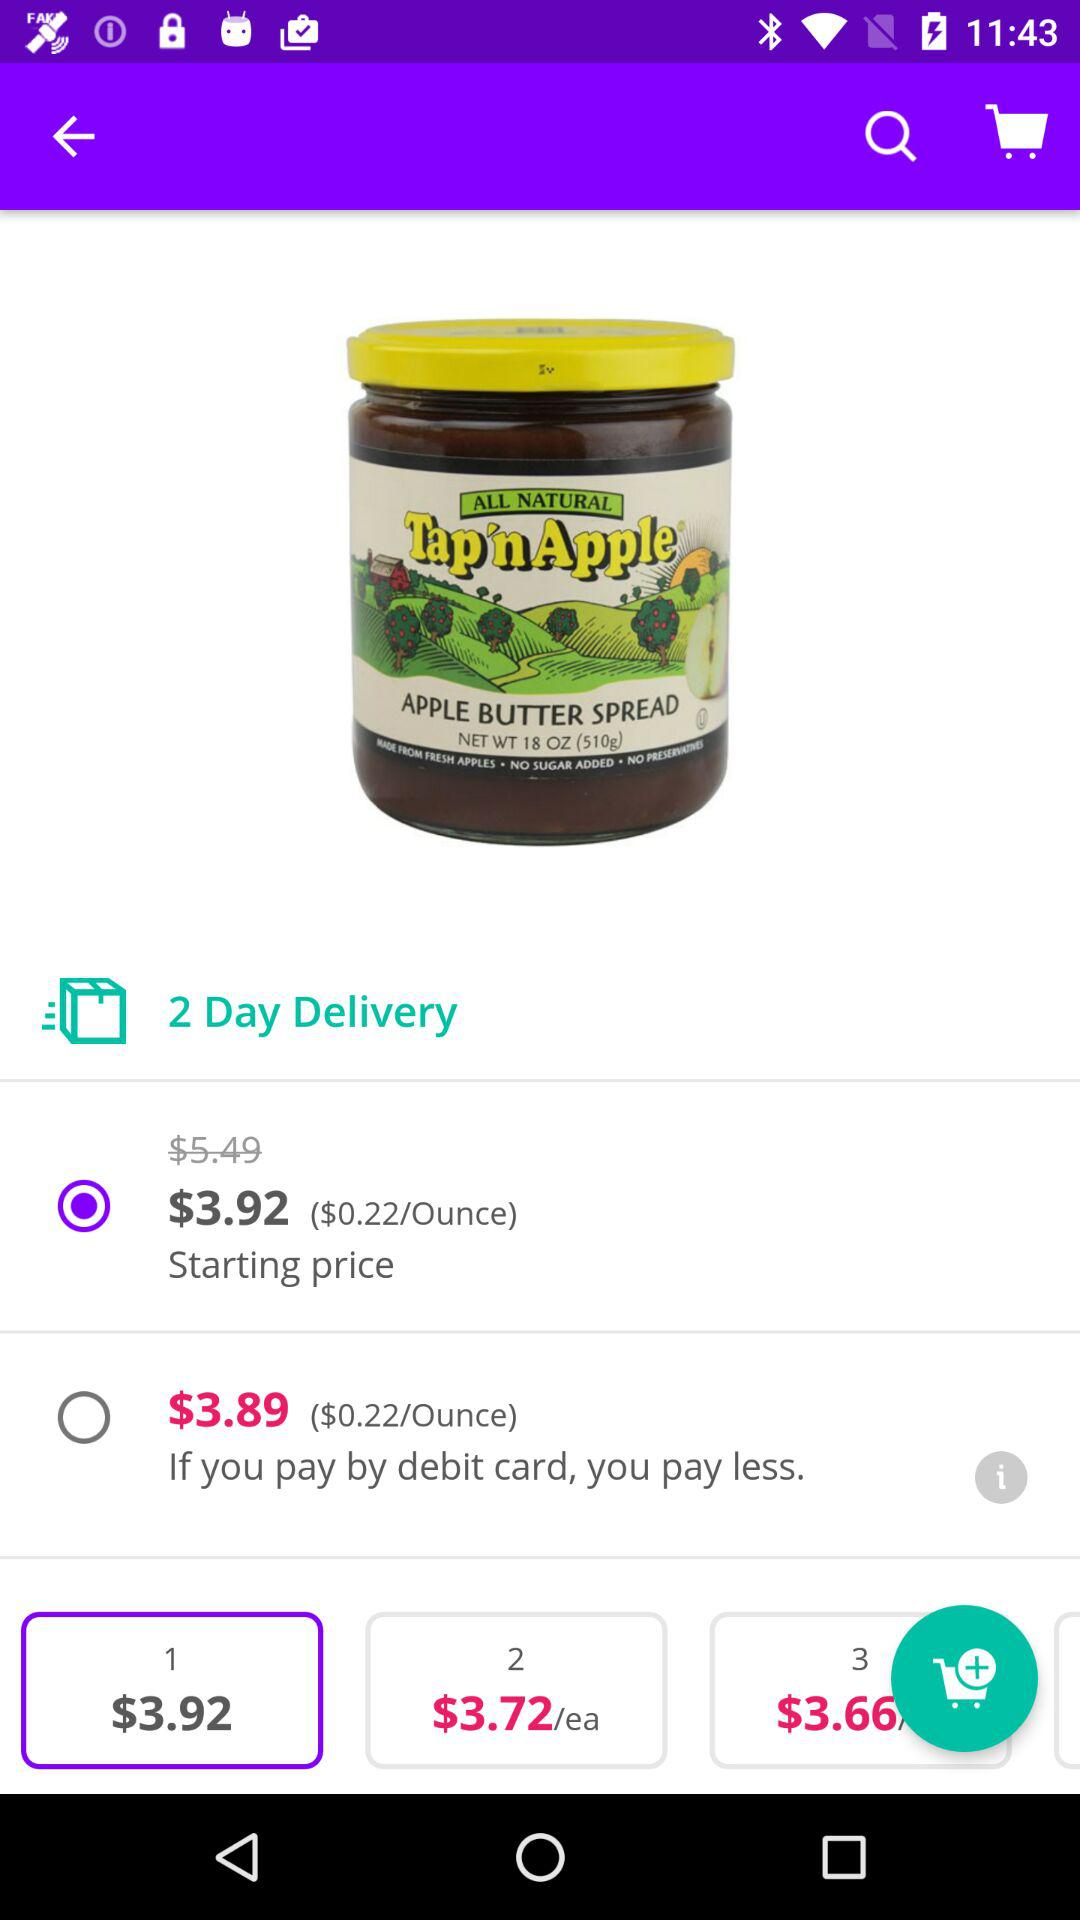What is the starting price of "APPLE BUTTER SPREAD"? The starting price is $3.92. 